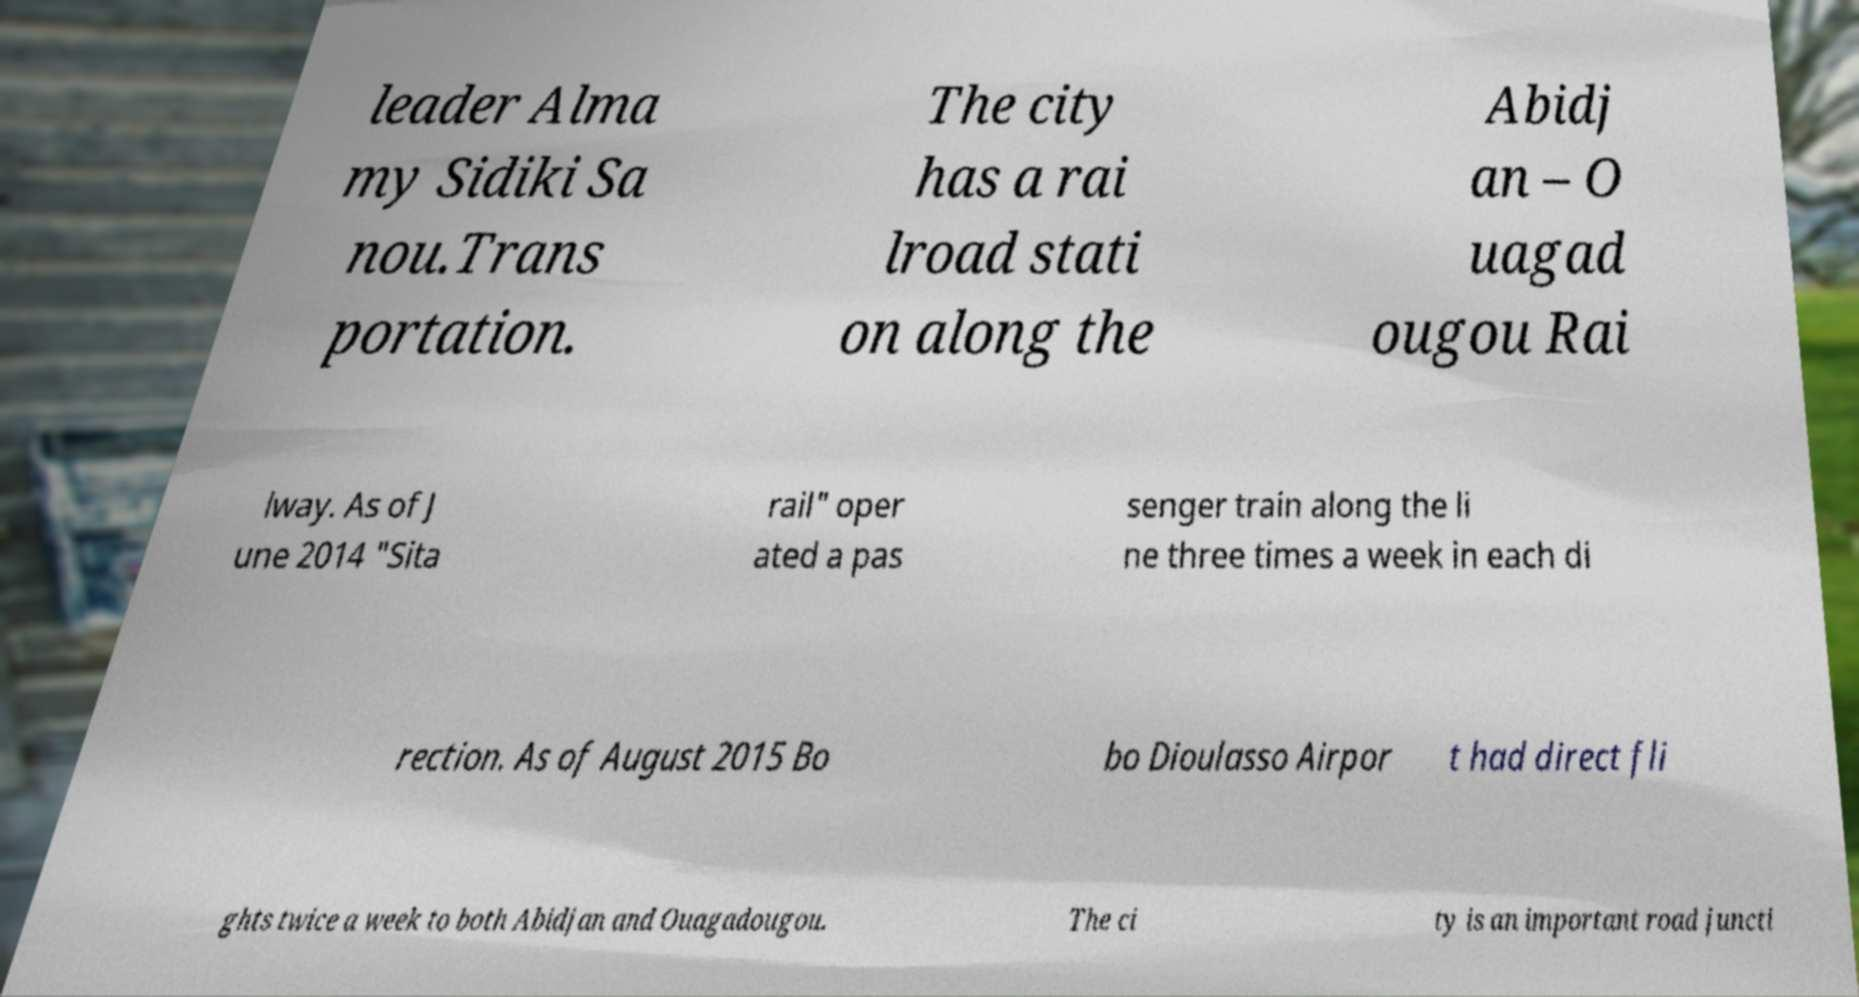For documentation purposes, I need the text within this image transcribed. Could you provide that? leader Alma my Sidiki Sa nou.Trans portation. The city has a rai lroad stati on along the Abidj an – O uagad ougou Rai lway. As of J une 2014 "Sita rail" oper ated a pas senger train along the li ne three times a week in each di rection. As of August 2015 Bo bo Dioulasso Airpor t had direct fli ghts twice a week to both Abidjan and Ouagadougou. The ci ty is an important road juncti 